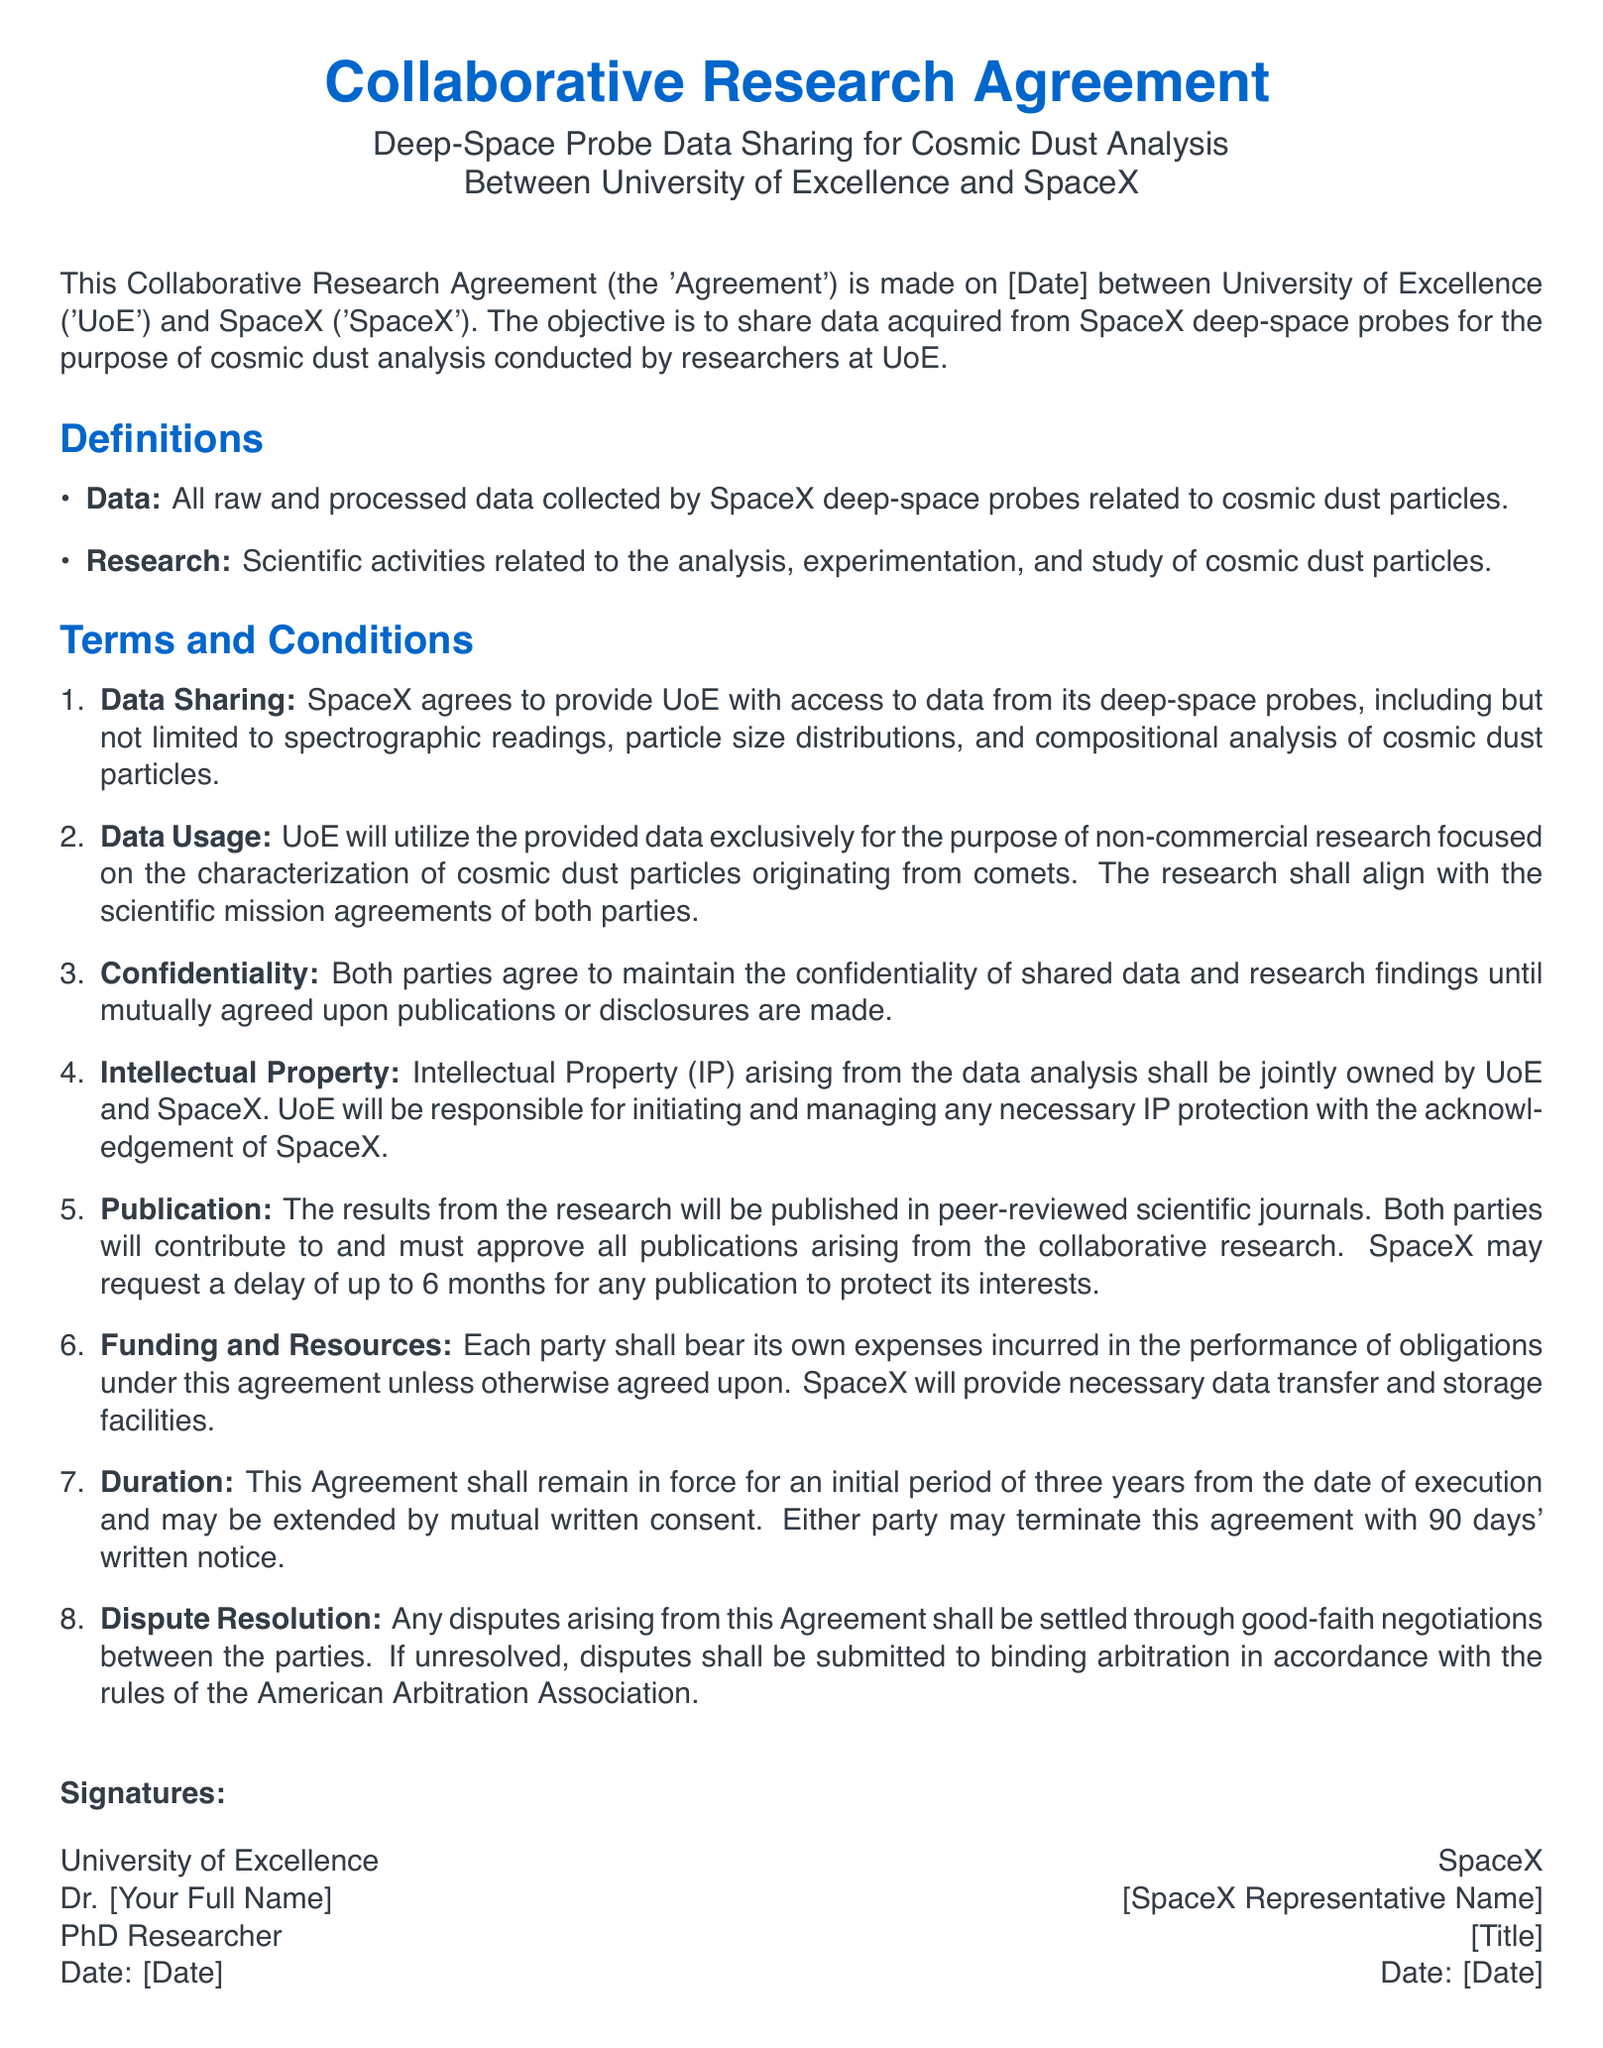What is the title of the agreement? The title of the agreement is specified at the beginning of the document.
Answer: Collaborative Research Agreement Who are the two parties involved in the agreement? The two parties mentioned in the document are clearly identified in the title section.
Answer: University of Excellence and SpaceX What is the purpose of the data sharing? The document outlines the objective of sharing data in relation to a specific research focus.
Answer: Cosmic dust analysis What is the duration of the agreement? The document states the initial duration of the agreement clearly in a specific section.
Answer: Three years What must both parties do before publishing research results? The document outlines a requirement pertaining to publication approval.
Answer: Approve all publications What type of expenses will each party bear? The agreement specifies who bears the expenses, which is a common detail in contract documents.
Answer: Own expenses What intellectual property rights are mentioned in the agreement? The agreement includes details regarding the ownership of intellectual property arising from the research.
Answer: Jointly owned How long can SpaceX delay publication of research results? The document provides a specific timeframe regarding publication delays requested by SpaceX.
Answer: Up to 6 months What method is outlined for dispute resolution? The document details the process to handle any disputes that may arise.
Answer: Binding arbitration 